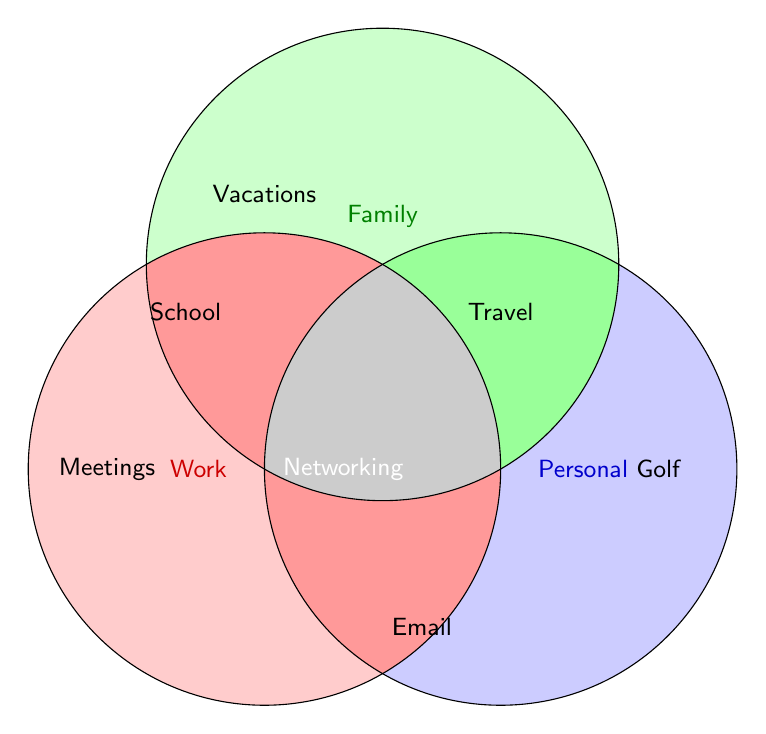How many areas are there on the Venn Diagram? Identify the number of distinct overlapping and non-overlapping areas created by the three circles.
Answer: 7 Which section represents all three time allocations? Look for the section where all three circles overlap.
Answer: Center Which activity is common to Work and Family but not Personal interests? Find the area where the Work and Family circles overlap without including the Personal interests circle.
Answer: Networking Which activities are only related to Family? Identify the area distinctly within the Family circle without overlapping with the other circles.
Answer: Vacations, School Which activities fall under Personal interests but not Work? Identify the areas within the Personal interests circle that do not overlap with the Work circle.
Answer: Golf, Travel What activity falls under both Work and Personal interests but not Family? Find the overlapping region between Work and Personal interests excluding Family.
Answer: Email Is "School" an activity related only to one area or multiple areas? Check if "School" appears only in the Family circle or overlaps with another.
Answer: One area Which activities are shared between Family and Personal interests but not Work? Identify activities in the overlapping region of Family and Personal interests that do not overlap with Work.
Answer: Travel What is the color used for the overlapping Work and Family areas? Look at the color in the region where only Work and Family circles overlap.
Answer: Red (darker shade) Which area in the diagram has no overlapping circles? Find the unique sections of each circle that don’t overlap with any other circle.
Answer: Golf, Vacations, Meetings 